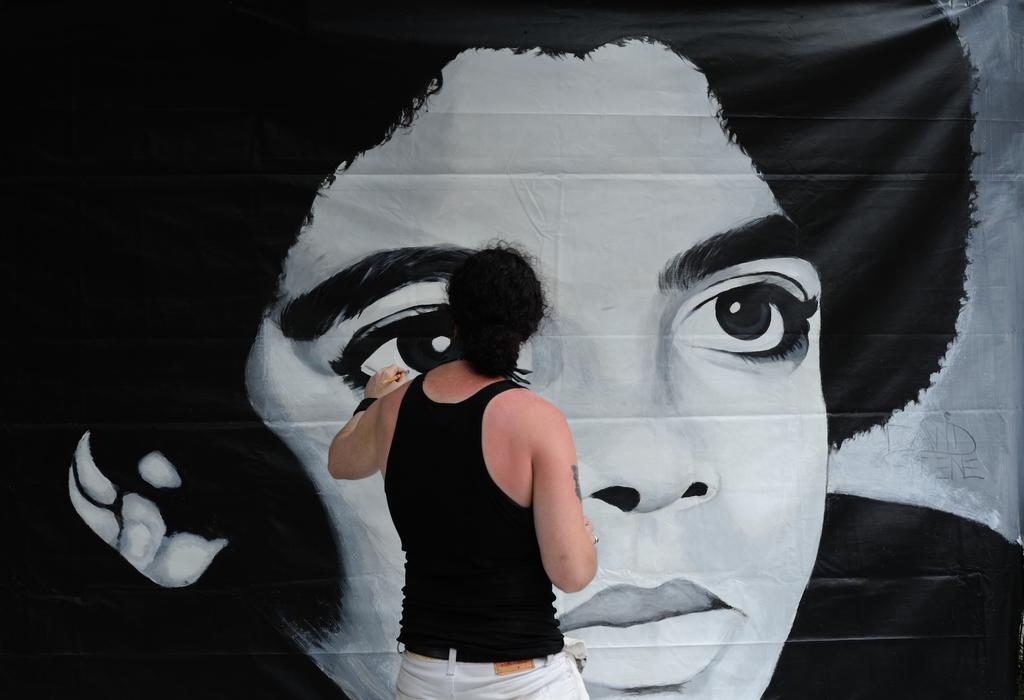Please provide a concise description of this image. In this picture we can see a man in the black tank top is standing and holding a brush. In front of the person there is painting on an item. 